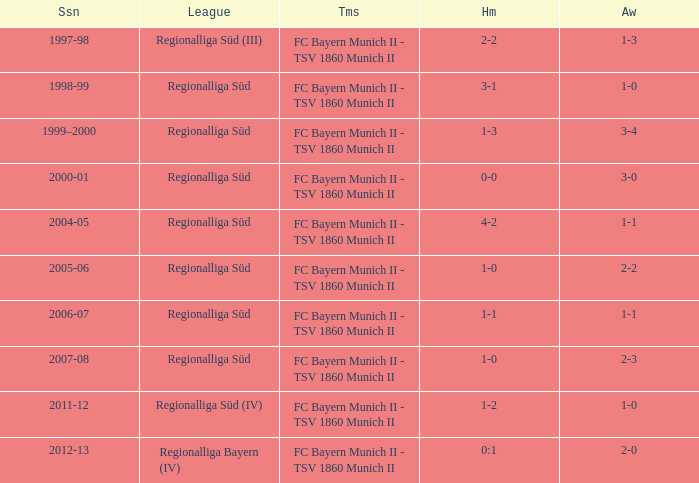Which season has the regionalliga süd (iii) league? 1997-98. Help me parse the entirety of this table. {'header': ['Ssn', 'League', 'Tms', 'Hm', 'Aw'], 'rows': [['1997-98', 'Regionalliga Süd (III)', 'FC Bayern Munich II - TSV 1860 Munich II', '2-2', '1-3'], ['1998-99', 'Regionalliga Süd', 'FC Bayern Munich II - TSV 1860 Munich II', '3-1', '1-0'], ['1999–2000', 'Regionalliga Süd', 'FC Bayern Munich II - TSV 1860 Munich II', '1-3', '3-4'], ['2000-01', 'Regionalliga Süd', 'FC Bayern Munich II - TSV 1860 Munich II', '0-0', '3-0'], ['2004-05', 'Regionalliga Süd', 'FC Bayern Munich II - TSV 1860 Munich II', '4-2', '1-1'], ['2005-06', 'Regionalliga Süd', 'FC Bayern Munich II - TSV 1860 Munich II', '1-0', '2-2'], ['2006-07', 'Regionalliga Süd', 'FC Bayern Munich II - TSV 1860 Munich II', '1-1', '1-1'], ['2007-08', 'Regionalliga Süd', 'FC Bayern Munich II - TSV 1860 Munich II', '1-0', '2-3'], ['2011-12', 'Regionalliga Süd (IV)', 'FC Bayern Munich II - TSV 1860 Munich II', '1-2', '1-0'], ['2012-13', 'Regionalliga Bayern (IV)', 'FC Bayern Munich II - TSV 1860 Munich II', '0:1', '2-0']]} 